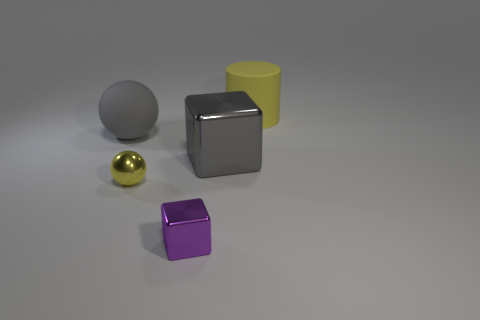What can you say about the arrangement and composition of the objects in the image? The composition of this image is quite balanced and minimalist. The objects are equally spaced and positioned strategically to create a visually appealing scene. The cube and cylinder form a triangle with the sphere, providing a good geometric contrast, and the selective use of color encourages the viewer's eye to move around the scene. 